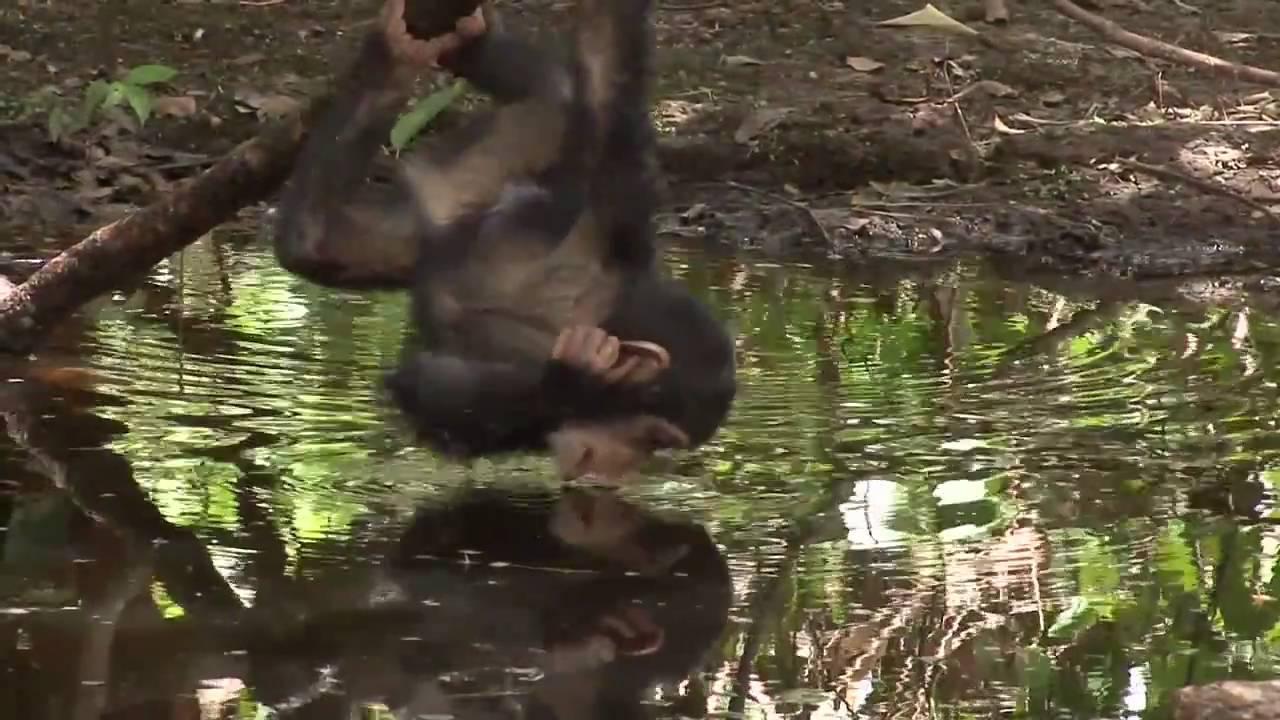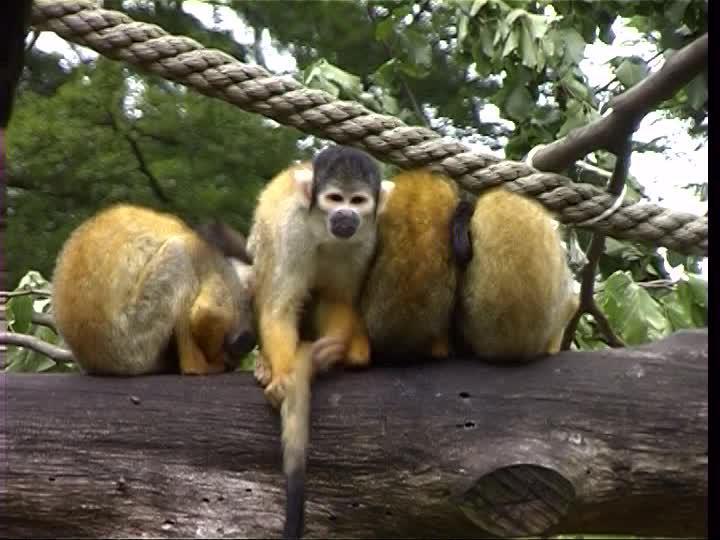The first image is the image on the left, the second image is the image on the right. For the images shown, is this caption "At least one of the chimps has their feet in water." true? Answer yes or no. No. The first image is the image on the left, the second image is the image on the right. Analyze the images presented: Is the assertion "The left image contains one left-facing chimp, and the right image features an ape splashing in water." valid? Answer yes or no. No. 